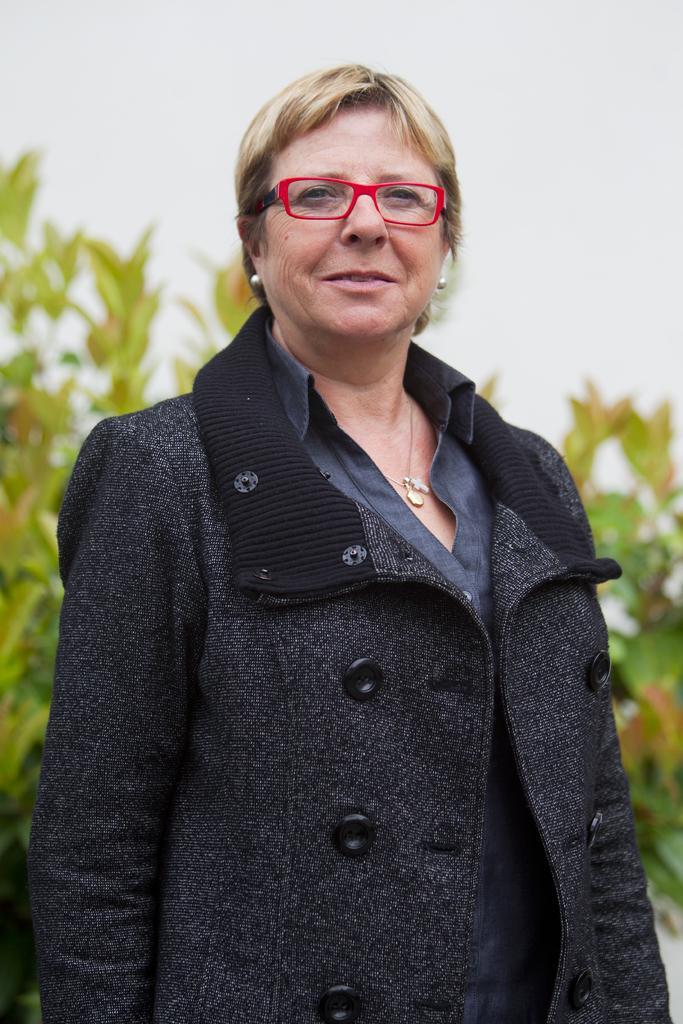Could you give a brief overview of what you see in this image? In this image we can see a woman wearing the glasses and standing. In the background we can see the plants and also the sky. 